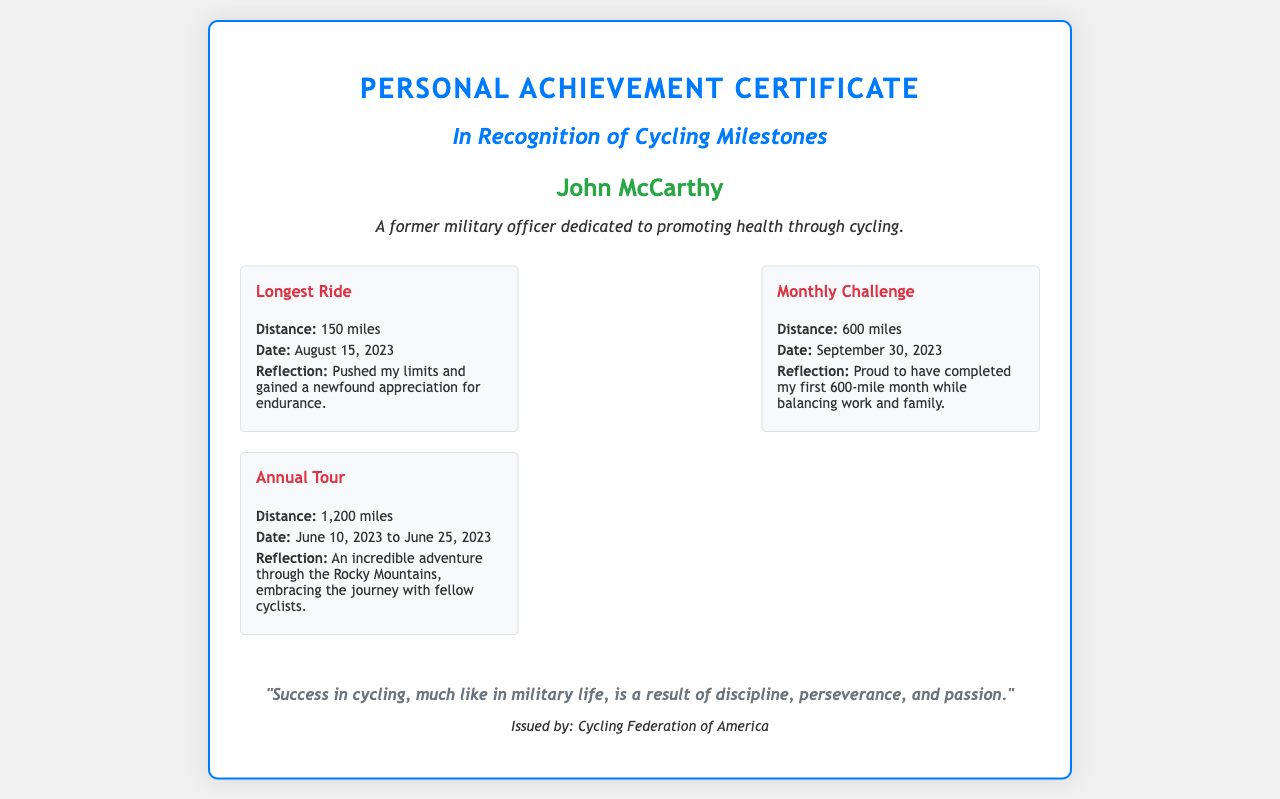What is the longest ride distance? The longest ride distance mentioned in the document is specified in a milestone as 150 miles.
Answer: 150 miles When was the monthly challenge completed? The completion date for the monthly challenge is included in its milestone, which states September 30, 2023.
Answer: September 30, 2023 Who issued the certificate? The issuer of the certificate is noted in the footer section as the Cycling Federation of America.
Answer: Cycling Federation of America Which cycling milestone reflects the most distance? The document contains information about various milestones, and the one with the most distance is the Annual Tour with 1,200 miles.
Answer: 1,200 miles What is John McCarthy's background? The document describes John McCarthy as a former military officer dedicated to promoting health through cycling.
Answer: Former military officer What did the recipient gain from the longest ride? The reflection for the longest ride indicates that the recipient gained a newfound appreciation for endurance.
Answer: Newfound appreciation for endurance How many miles were completed in the monthly challenge? The distance completed during the monthly challenge is explicitly stated as 600 miles.
Answer: 600 miles What type of certificate is this? The document is specifically a Personal Achievement Certificate recognizing cycling milestones.
Answer: Personal Achievement Certificate 